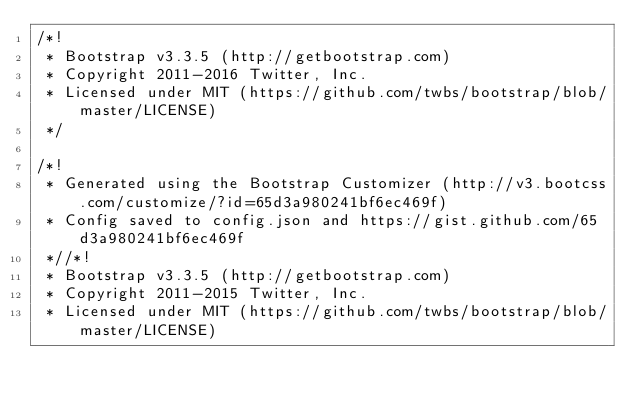<code> <loc_0><loc_0><loc_500><loc_500><_CSS_>/*!
 * Bootstrap v3.3.5 (http://getbootstrap.com)
 * Copyright 2011-2016 Twitter, Inc.
 * Licensed under MIT (https://github.com/twbs/bootstrap/blob/master/LICENSE)
 */

/*!
 * Generated using the Bootstrap Customizer (http://v3.bootcss.com/customize/?id=65d3a980241bf6ec469f)
 * Config saved to config.json and https://gist.github.com/65d3a980241bf6ec469f
 *//*!
 * Bootstrap v3.3.5 (http://getbootstrap.com)
 * Copyright 2011-2015 Twitter, Inc.
 * Licensed under MIT (https://github.com/twbs/bootstrap/blob/master/LICENSE)</code> 